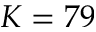Convert formula to latex. <formula><loc_0><loc_0><loc_500><loc_500>K = 7 9</formula> 